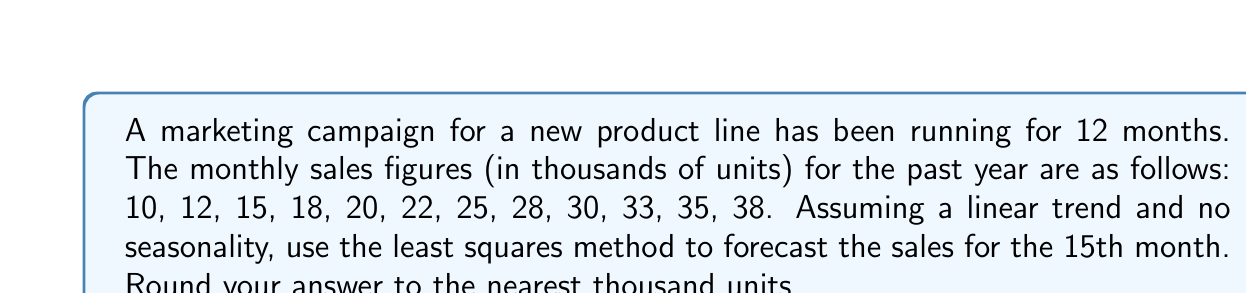Can you solve this math problem? To forecast future sales using time series analysis with a linear trend, we'll use the least squares method:

1) Let $y_i$ be the sales and $x_i$ be the time period (month number).

2) We need to calculate:
   $\bar{x} = \frac{\sum x_i}{n}$, $\bar{y} = \frac{\sum y_i}{n}$
   $S_{xx} = \sum (x_i - \bar{x})^2$, $S_{xy} = \sum (x_i - \bar{x})(y_i - \bar{y})$

3) $\sum x_i = 1 + 2 + ... + 12 = 78$, $n = 12$
   $\bar{x} = 78 / 12 = 6.5$

4) $\sum y_i = 10 + 12 + ... + 38 = 286$
   $\bar{y} = 286 / 12 = 23.833$

5) $S_{xx} = (1-6.5)^2 + (2-6.5)^2 + ... + (12-6.5)^2 = 143$

6) $S_{xy} = (1-6.5)(10-23.833) + ... + (12-6.5)(38-23.833) = 371.5$

7) The slope $b_1 = \frac{S_{xy}}{S_{xx}} = 371.5 / 143 = 2.598$

8) The intercept $b_0 = \bar{y} - b_1\bar{x} = 23.833 - 2.598(6.5) = 6.946$

9) The linear trend equation is:
   $y = 6.946 + 2.598x$

10) For the 15th month, $x = 15$:
    $y = 6.946 + 2.598(15) = 45.916$

11) Rounding to the nearest thousand: 46,000 units
Answer: 46,000 units 